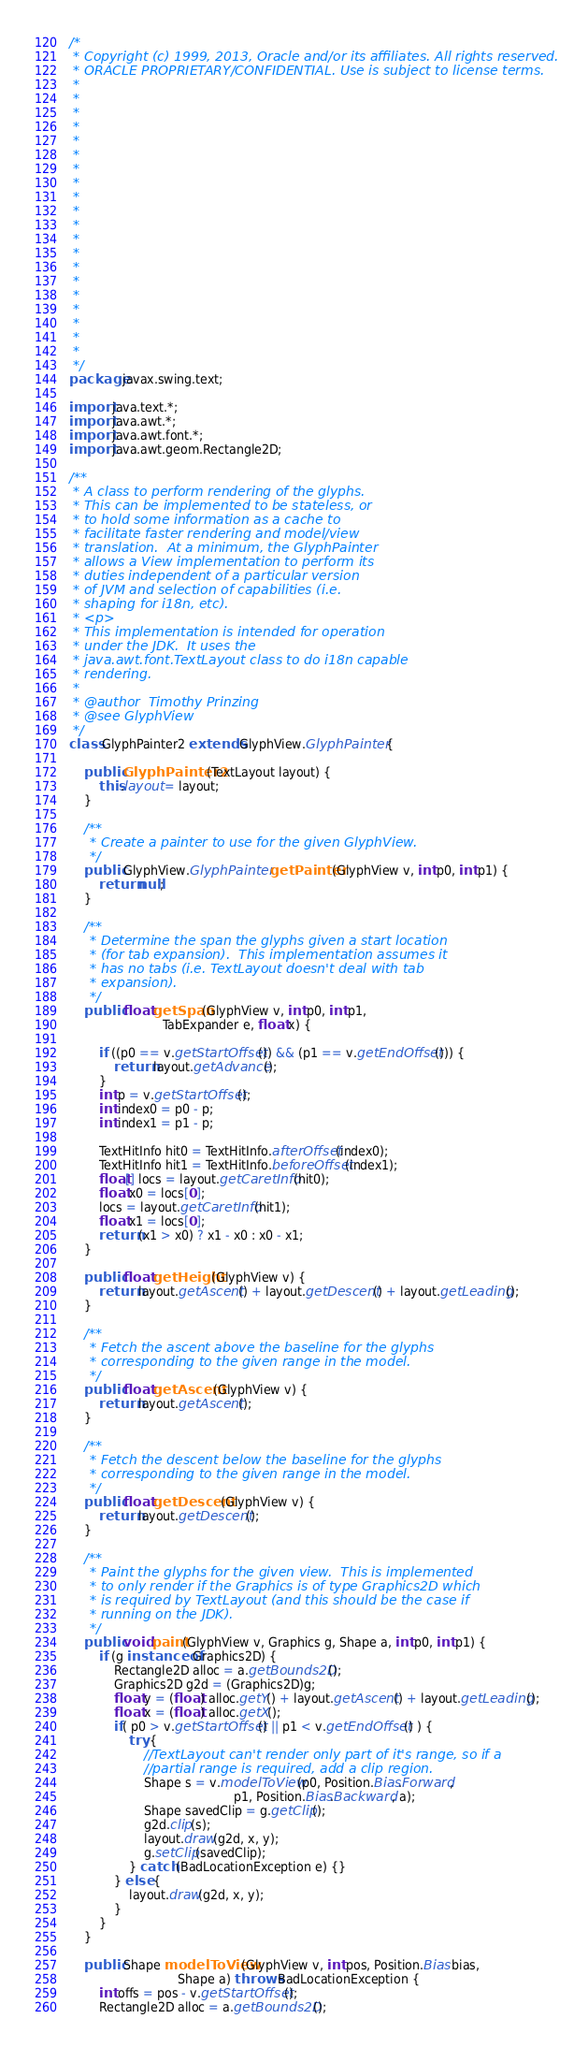<code> <loc_0><loc_0><loc_500><loc_500><_Java_>/*
 * Copyright (c) 1999, 2013, Oracle and/or its affiliates. All rights reserved.
 * ORACLE PROPRIETARY/CONFIDENTIAL. Use is subject to license terms.
 *
 *
 *
 *
 *
 *
 *
 *
 *
 *
 *
 *
 *
 *
 *
 *
 *
 *
 *
 *
 */
package javax.swing.text;

import java.text.*;
import java.awt.*;
import java.awt.font.*;
import java.awt.geom.Rectangle2D;

/**
 * A class to perform rendering of the glyphs.
 * This can be implemented to be stateless, or
 * to hold some information as a cache to
 * facilitate faster rendering and model/view
 * translation.  At a minimum, the GlyphPainter
 * allows a View implementation to perform its
 * duties independent of a particular version
 * of JVM and selection of capabilities (i.e.
 * shaping for i18n, etc).
 * <p>
 * This implementation is intended for operation
 * under the JDK.  It uses the
 * java.awt.font.TextLayout class to do i18n capable
 * rendering.
 *
 * @author  Timothy Prinzing
 * @see GlyphView
 */
class GlyphPainter2 extends GlyphView.GlyphPainter {

    public GlyphPainter2(TextLayout layout) {
        this.layout = layout;
    }

    /**
     * Create a painter to use for the given GlyphView.
     */
    public GlyphView.GlyphPainter getPainter(GlyphView v, int p0, int p1) {
        return null;
    }

    /**
     * Determine the span the glyphs given a start location
     * (for tab expansion).  This implementation assumes it
     * has no tabs (i.e. TextLayout doesn't deal with tab
     * expansion).
     */
    public float getSpan(GlyphView v, int p0, int p1,
                         TabExpander e, float x) {

        if ((p0 == v.getStartOffset()) && (p1 == v.getEndOffset())) {
            return layout.getAdvance();
        }
        int p = v.getStartOffset();
        int index0 = p0 - p;
        int index1 = p1 - p;

        TextHitInfo hit0 = TextHitInfo.afterOffset(index0);
        TextHitInfo hit1 = TextHitInfo.beforeOffset(index1);
        float[] locs = layout.getCaretInfo(hit0);
        float x0 = locs[0];
        locs = layout.getCaretInfo(hit1);
        float x1 = locs[0];
        return (x1 > x0) ? x1 - x0 : x0 - x1;
    }

    public float getHeight(GlyphView v) {
        return layout.getAscent() + layout.getDescent() + layout.getLeading();
    }

    /**
     * Fetch the ascent above the baseline for the glyphs
     * corresponding to the given range in the model.
     */
    public float getAscent(GlyphView v) {
        return layout.getAscent();
    }

    /**
     * Fetch the descent below the baseline for the glyphs
     * corresponding to the given range in the model.
     */
    public float getDescent(GlyphView v) {
        return layout.getDescent();
    }

    /**
     * Paint the glyphs for the given view.  This is implemented
     * to only render if the Graphics is of type Graphics2D which
     * is required by TextLayout (and this should be the case if
     * running on the JDK).
     */
    public void paint(GlyphView v, Graphics g, Shape a, int p0, int p1) {
        if (g instanceof Graphics2D) {
            Rectangle2D alloc = a.getBounds2D();
            Graphics2D g2d = (Graphics2D)g;
            float y = (float) alloc.getY() + layout.getAscent() + layout.getLeading();
            float x = (float) alloc.getX();
            if( p0 > v.getStartOffset() || p1 < v.getEndOffset() ) {
                try {
                    //TextLayout can't render only part of it's range, so if a
                    //partial range is required, add a clip region.
                    Shape s = v.modelToView(p0, Position.Bias.Forward,
                                            p1, Position.Bias.Backward, a);
                    Shape savedClip = g.getClip();
                    g2d.clip(s);
                    layout.draw(g2d, x, y);
                    g.setClip(savedClip);
                } catch (BadLocationException e) {}
            } else {
                layout.draw(g2d, x, y);
            }
        }
    }

    public Shape modelToView(GlyphView v, int pos, Position.Bias bias,
                             Shape a) throws BadLocationException {
        int offs = pos - v.getStartOffset();
        Rectangle2D alloc = a.getBounds2D();</code> 